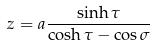Convert formula to latex. <formula><loc_0><loc_0><loc_500><loc_500>z = a \frac { \sinh \tau } { \cosh \tau - \cos \sigma }</formula> 